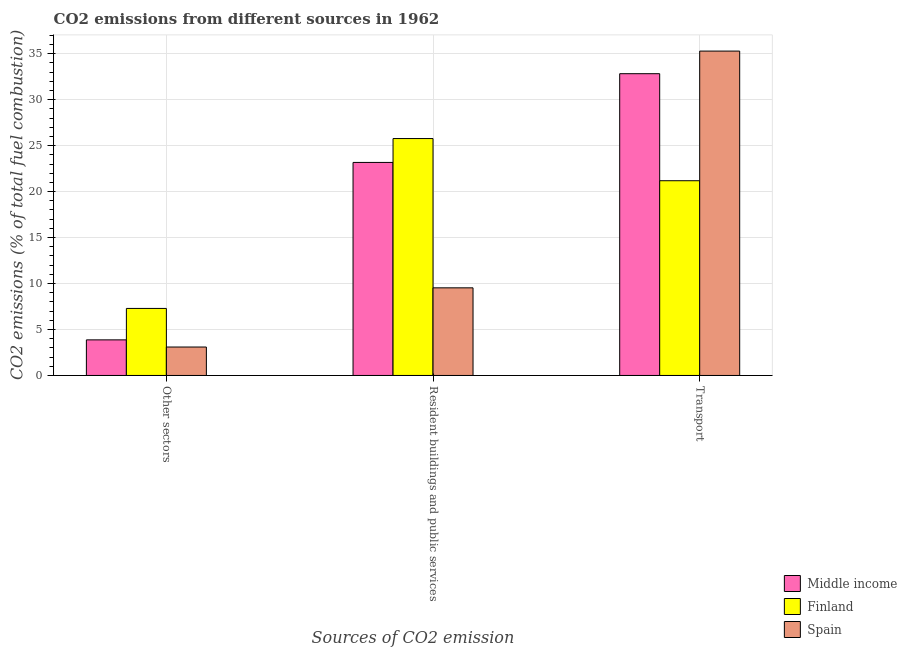How many groups of bars are there?
Make the answer very short. 3. How many bars are there on the 3rd tick from the left?
Provide a short and direct response. 3. How many bars are there on the 2nd tick from the right?
Your answer should be compact. 3. What is the label of the 1st group of bars from the left?
Keep it short and to the point. Other sectors. What is the percentage of co2 emissions from other sectors in Finland?
Your answer should be compact. 7.29. Across all countries, what is the maximum percentage of co2 emissions from transport?
Your answer should be compact. 35.28. Across all countries, what is the minimum percentage of co2 emissions from transport?
Offer a very short reply. 21.18. What is the total percentage of co2 emissions from transport in the graph?
Make the answer very short. 89.29. What is the difference between the percentage of co2 emissions from other sectors in Middle income and that in Spain?
Offer a very short reply. 0.78. What is the difference between the percentage of co2 emissions from transport in Finland and the percentage of co2 emissions from resident buildings and public services in Middle income?
Make the answer very short. -1.99. What is the average percentage of co2 emissions from transport per country?
Your answer should be compact. 29.76. What is the difference between the percentage of co2 emissions from other sectors and percentage of co2 emissions from transport in Finland?
Provide a succinct answer. -13.89. What is the ratio of the percentage of co2 emissions from resident buildings and public services in Spain to that in Finland?
Give a very brief answer. 0.37. Is the percentage of co2 emissions from transport in Middle income less than that in Spain?
Your response must be concise. Yes. Is the difference between the percentage of co2 emissions from transport in Spain and Middle income greater than the difference between the percentage of co2 emissions from resident buildings and public services in Spain and Middle income?
Give a very brief answer. Yes. What is the difference between the highest and the second highest percentage of co2 emissions from resident buildings and public services?
Keep it short and to the point. 2.6. What is the difference between the highest and the lowest percentage of co2 emissions from transport?
Make the answer very short. 14.1. In how many countries, is the percentage of co2 emissions from other sectors greater than the average percentage of co2 emissions from other sectors taken over all countries?
Your answer should be compact. 1. What does the 3rd bar from the left in Resident buildings and public services represents?
Your answer should be compact. Spain. Is it the case that in every country, the sum of the percentage of co2 emissions from other sectors and percentage of co2 emissions from resident buildings and public services is greater than the percentage of co2 emissions from transport?
Make the answer very short. No. How many bars are there?
Offer a very short reply. 9. Are all the bars in the graph horizontal?
Make the answer very short. No. What is the difference between two consecutive major ticks on the Y-axis?
Provide a short and direct response. 5. Are the values on the major ticks of Y-axis written in scientific E-notation?
Your response must be concise. No. Does the graph contain grids?
Ensure brevity in your answer.  Yes. What is the title of the graph?
Offer a very short reply. CO2 emissions from different sources in 1962. What is the label or title of the X-axis?
Provide a short and direct response. Sources of CO2 emission. What is the label or title of the Y-axis?
Ensure brevity in your answer.  CO2 emissions (% of total fuel combustion). What is the CO2 emissions (% of total fuel combustion) in Middle income in Other sectors?
Offer a terse response. 3.87. What is the CO2 emissions (% of total fuel combustion) in Finland in Other sectors?
Keep it short and to the point. 7.29. What is the CO2 emissions (% of total fuel combustion) in Spain in Other sectors?
Offer a very short reply. 3.09. What is the CO2 emissions (% of total fuel combustion) in Middle income in Resident buildings and public services?
Provide a short and direct response. 23.17. What is the CO2 emissions (% of total fuel combustion) in Finland in Resident buildings and public services?
Offer a terse response. 25.77. What is the CO2 emissions (% of total fuel combustion) in Spain in Resident buildings and public services?
Your response must be concise. 9.53. What is the CO2 emissions (% of total fuel combustion) of Middle income in Transport?
Keep it short and to the point. 32.82. What is the CO2 emissions (% of total fuel combustion) of Finland in Transport?
Make the answer very short. 21.18. What is the CO2 emissions (% of total fuel combustion) in Spain in Transport?
Provide a short and direct response. 35.28. Across all Sources of CO2 emission, what is the maximum CO2 emissions (% of total fuel combustion) in Middle income?
Keep it short and to the point. 32.82. Across all Sources of CO2 emission, what is the maximum CO2 emissions (% of total fuel combustion) in Finland?
Make the answer very short. 25.77. Across all Sources of CO2 emission, what is the maximum CO2 emissions (% of total fuel combustion) in Spain?
Ensure brevity in your answer.  35.28. Across all Sources of CO2 emission, what is the minimum CO2 emissions (% of total fuel combustion) of Middle income?
Your response must be concise. 3.87. Across all Sources of CO2 emission, what is the minimum CO2 emissions (% of total fuel combustion) of Finland?
Keep it short and to the point. 7.29. Across all Sources of CO2 emission, what is the minimum CO2 emissions (% of total fuel combustion) of Spain?
Ensure brevity in your answer.  3.09. What is the total CO2 emissions (% of total fuel combustion) in Middle income in the graph?
Make the answer very short. 59.87. What is the total CO2 emissions (% of total fuel combustion) of Finland in the graph?
Offer a terse response. 54.24. What is the total CO2 emissions (% of total fuel combustion) of Spain in the graph?
Your answer should be compact. 47.91. What is the difference between the CO2 emissions (% of total fuel combustion) of Middle income in Other sectors and that in Resident buildings and public services?
Ensure brevity in your answer.  -19.3. What is the difference between the CO2 emissions (% of total fuel combustion) of Finland in Other sectors and that in Resident buildings and public services?
Provide a short and direct response. -18.48. What is the difference between the CO2 emissions (% of total fuel combustion) in Spain in Other sectors and that in Resident buildings and public services?
Your response must be concise. -6.44. What is the difference between the CO2 emissions (% of total fuel combustion) in Middle income in Other sectors and that in Transport?
Your response must be concise. -28.95. What is the difference between the CO2 emissions (% of total fuel combustion) of Finland in Other sectors and that in Transport?
Make the answer very short. -13.89. What is the difference between the CO2 emissions (% of total fuel combustion) in Spain in Other sectors and that in Transport?
Make the answer very short. -32.19. What is the difference between the CO2 emissions (% of total fuel combustion) of Middle income in Resident buildings and public services and that in Transport?
Offer a very short reply. -9.65. What is the difference between the CO2 emissions (% of total fuel combustion) in Finland in Resident buildings and public services and that in Transport?
Your answer should be very brief. 4.59. What is the difference between the CO2 emissions (% of total fuel combustion) of Spain in Resident buildings and public services and that in Transport?
Your response must be concise. -25.75. What is the difference between the CO2 emissions (% of total fuel combustion) of Middle income in Other sectors and the CO2 emissions (% of total fuel combustion) of Finland in Resident buildings and public services?
Provide a short and direct response. -21.9. What is the difference between the CO2 emissions (% of total fuel combustion) in Middle income in Other sectors and the CO2 emissions (% of total fuel combustion) in Spain in Resident buildings and public services?
Your answer should be very brief. -5.66. What is the difference between the CO2 emissions (% of total fuel combustion) of Finland in Other sectors and the CO2 emissions (% of total fuel combustion) of Spain in Resident buildings and public services?
Give a very brief answer. -2.24. What is the difference between the CO2 emissions (% of total fuel combustion) in Middle income in Other sectors and the CO2 emissions (% of total fuel combustion) in Finland in Transport?
Offer a terse response. -17.31. What is the difference between the CO2 emissions (% of total fuel combustion) in Middle income in Other sectors and the CO2 emissions (% of total fuel combustion) in Spain in Transport?
Your answer should be very brief. -31.41. What is the difference between the CO2 emissions (% of total fuel combustion) of Finland in Other sectors and the CO2 emissions (% of total fuel combustion) of Spain in Transport?
Give a very brief answer. -27.99. What is the difference between the CO2 emissions (% of total fuel combustion) of Middle income in Resident buildings and public services and the CO2 emissions (% of total fuel combustion) of Finland in Transport?
Offer a very short reply. 1.99. What is the difference between the CO2 emissions (% of total fuel combustion) in Middle income in Resident buildings and public services and the CO2 emissions (% of total fuel combustion) in Spain in Transport?
Your answer should be compact. -12.11. What is the difference between the CO2 emissions (% of total fuel combustion) in Finland in Resident buildings and public services and the CO2 emissions (% of total fuel combustion) in Spain in Transport?
Ensure brevity in your answer.  -9.51. What is the average CO2 emissions (% of total fuel combustion) of Middle income per Sources of CO2 emission?
Give a very brief answer. 19.96. What is the average CO2 emissions (% of total fuel combustion) of Finland per Sources of CO2 emission?
Keep it short and to the point. 18.08. What is the average CO2 emissions (% of total fuel combustion) of Spain per Sources of CO2 emission?
Keep it short and to the point. 15.97. What is the difference between the CO2 emissions (% of total fuel combustion) of Middle income and CO2 emissions (% of total fuel combustion) of Finland in Other sectors?
Give a very brief answer. -3.42. What is the difference between the CO2 emissions (% of total fuel combustion) of Middle income and CO2 emissions (% of total fuel combustion) of Spain in Other sectors?
Your answer should be very brief. 0.78. What is the difference between the CO2 emissions (% of total fuel combustion) of Finland and CO2 emissions (% of total fuel combustion) of Spain in Other sectors?
Your response must be concise. 4.2. What is the difference between the CO2 emissions (% of total fuel combustion) in Middle income and CO2 emissions (% of total fuel combustion) in Finland in Resident buildings and public services?
Provide a short and direct response. -2.6. What is the difference between the CO2 emissions (% of total fuel combustion) in Middle income and CO2 emissions (% of total fuel combustion) in Spain in Resident buildings and public services?
Your answer should be very brief. 13.64. What is the difference between the CO2 emissions (% of total fuel combustion) in Finland and CO2 emissions (% of total fuel combustion) in Spain in Resident buildings and public services?
Provide a succinct answer. 16.24. What is the difference between the CO2 emissions (% of total fuel combustion) of Middle income and CO2 emissions (% of total fuel combustion) of Finland in Transport?
Keep it short and to the point. 11.64. What is the difference between the CO2 emissions (% of total fuel combustion) of Middle income and CO2 emissions (% of total fuel combustion) of Spain in Transport?
Your answer should be compact. -2.46. What is the difference between the CO2 emissions (% of total fuel combustion) of Finland and CO2 emissions (% of total fuel combustion) of Spain in Transport?
Make the answer very short. -14.1. What is the ratio of the CO2 emissions (% of total fuel combustion) of Middle income in Other sectors to that in Resident buildings and public services?
Ensure brevity in your answer.  0.17. What is the ratio of the CO2 emissions (% of total fuel combustion) of Finland in Other sectors to that in Resident buildings and public services?
Give a very brief answer. 0.28. What is the ratio of the CO2 emissions (% of total fuel combustion) in Spain in Other sectors to that in Resident buildings and public services?
Offer a terse response. 0.32. What is the ratio of the CO2 emissions (% of total fuel combustion) in Middle income in Other sectors to that in Transport?
Your response must be concise. 0.12. What is the ratio of the CO2 emissions (% of total fuel combustion) of Finland in Other sectors to that in Transport?
Provide a short and direct response. 0.34. What is the ratio of the CO2 emissions (% of total fuel combustion) of Spain in Other sectors to that in Transport?
Your response must be concise. 0.09. What is the ratio of the CO2 emissions (% of total fuel combustion) of Middle income in Resident buildings and public services to that in Transport?
Your response must be concise. 0.71. What is the ratio of the CO2 emissions (% of total fuel combustion) in Finland in Resident buildings and public services to that in Transport?
Ensure brevity in your answer.  1.22. What is the ratio of the CO2 emissions (% of total fuel combustion) of Spain in Resident buildings and public services to that in Transport?
Provide a short and direct response. 0.27. What is the difference between the highest and the second highest CO2 emissions (% of total fuel combustion) of Middle income?
Your response must be concise. 9.65. What is the difference between the highest and the second highest CO2 emissions (% of total fuel combustion) in Finland?
Your answer should be compact. 4.59. What is the difference between the highest and the second highest CO2 emissions (% of total fuel combustion) in Spain?
Offer a terse response. 25.75. What is the difference between the highest and the lowest CO2 emissions (% of total fuel combustion) in Middle income?
Keep it short and to the point. 28.95. What is the difference between the highest and the lowest CO2 emissions (% of total fuel combustion) in Finland?
Provide a short and direct response. 18.48. What is the difference between the highest and the lowest CO2 emissions (% of total fuel combustion) in Spain?
Ensure brevity in your answer.  32.19. 